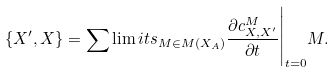Convert formula to latex. <formula><loc_0><loc_0><loc_500><loc_500>\{ X ^ { \prime } , X \} = \sum \lim i t s _ { M \in M ( X _ { A } ) } \frac { \partial c _ { X , X ^ { \prime } } ^ { M } } { \partial t } \Big | _ { t = 0 } M .</formula> 